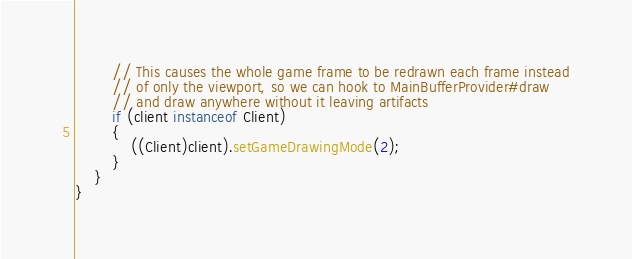<code> <loc_0><loc_0><loc_500><loc_500><_Java_>
		// This causes the whole game frame to be redrawn each frame instead
		// of only the viewport, so we can hook to MainBufferProvider#draw
		// and draw anywhere without it leaving artifacts
		if (client instanceof Client)
		{
			((Client)client).setGameDrawingMode(2);
		}
	}
}</code> 